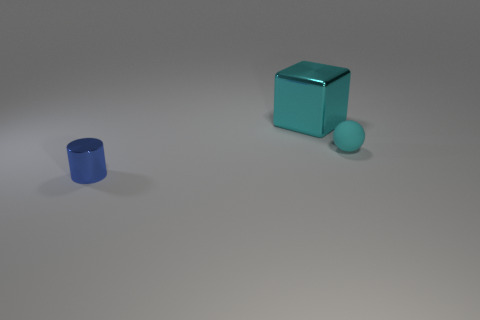There is a big shiny cube; is its color the same as the small object that is right of the tiny cylinder?
Offer a very short reply. Yes. How many other objects are the same size as the cube?
Your answer should be compact. 0. What is the shape of the shiny thing in front of the cyan thing that is behind the cyan object to the right of the large cyan metallic object?
Your answer should be very brief. Cylinder. There is a cyan metal thing; does it have the same size as the shiny thing in front of the small cyan thing?
Your response must be concise. No. What is the color of the thing that is in front of the large cyan block and left of the cyan ball?
Ensure brevity in your answer.  Blue. What number of other objects are the same shape as the tiny cyan thing?
Offer a very short reply. 0. There is a tiny thing that is on the right side of the large cyan shiny block; is it the same color as the metal thing on the right side of the small shiny object?
Offer a very short reply. Yes. There is a cyan thing that is in front of the cyan metal object; is its size the same as the metal object that is behind the metal cylinder?
Keep it short and to the point. No. Are there any other things that are the same material as the small cyan object?
Offer a terse response. No. There is a thing that is behind the cyan object that is on the right side of the cyan object that is behind the cyan ball; what is its material?
Provide a short and direct response. Metal. 